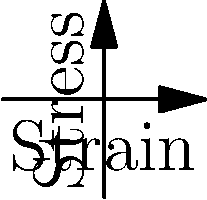In a cinematic scene depicting a structural failure, which material would create the most dramatic visual impact if stressed beyond its yield point, considering the stress-strain curves shown for materials A, B, and C? To answer this question, we need to analyze the stress-strain curves for each material and consider their implications for visual storytelling:

1. Material A (blue curve):
   - Shows a non-linear relationship between stress and strain.
   - The curve is concave upward, indicating strain hardening.
   - Beyond the yield point, it would continue to deform while resisting increased load.

2. Material B (red curve):
   - Exhibits a linear relationship between stress and strain.
   - This suggests elastic behavior up to the yield point.
   - Beyond yield, it would likely experience sudden failure.

3. Material C (green curve):
   - Demonstrates a non-linear relationship with a decreasing slope.
   - This indicates strain softening behavior.
   - Beyond yield, it would continue to deform with decreasing resistance.

From a cinematic perspective, Material B would create the most dramatic visual impact. Its linear stress-strain relationship suggests brittle behavior, which would result in a sudden, catastrophic failure when stressed beyond its yield point. This abrupt collapse would be visually striking and tension-building for the audience.

Material A would show a more gradual deformation, while Material C would exhibit a slow, progressive failure. Both of these would be less visually impactful than the sudden failure of Material B.
Answer: Material B 